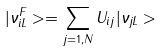Convert formula to latex. <formula><loc_0><loc_0><loc_500><loc_500>| \nu ^ { F } _ { i L } > = \sum _ { j = 1 , N } U _ { i j } | \nu _ { j L } ></formula> 